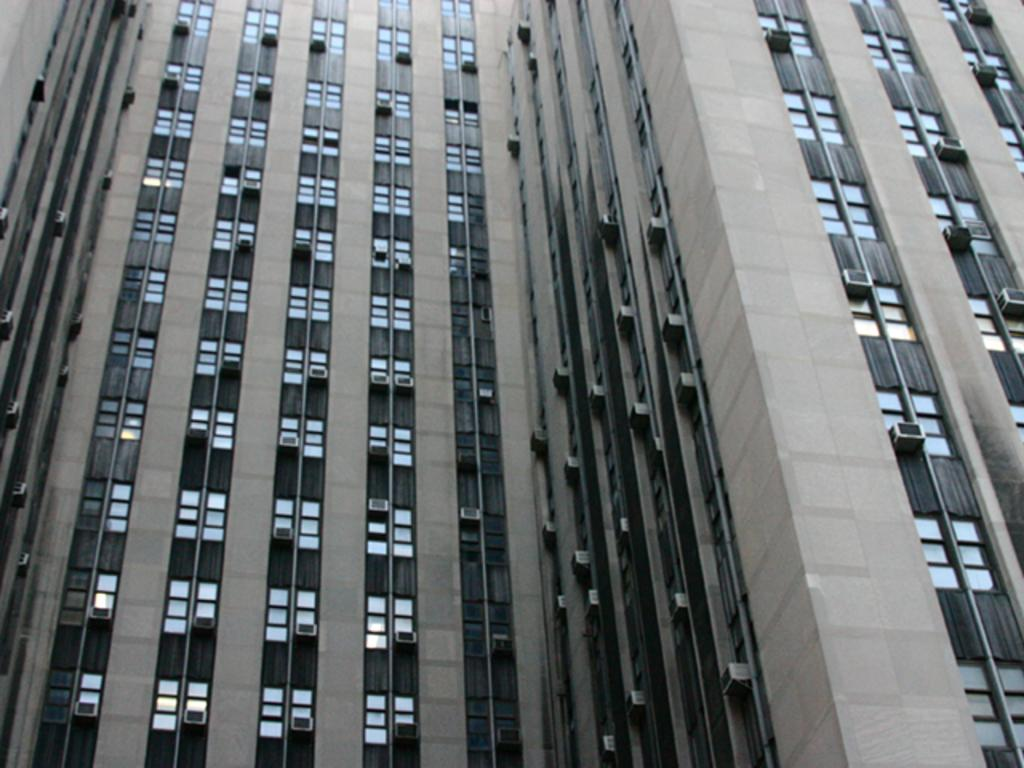What type of structure is visible in the image? There is a building in the image. What feature can be observed on the building? The building has multiple glass windows. What device is present on the building to regulate temperature? There is an air conditioning unit present on the building. What is the price of the cannon on the roof of the building in the image? There is no cannon present on the roof of the building in the image. How many beds are visible in the image? There are no beds visible in the image; it only features a building with glass windows and an air conditioning unit. 